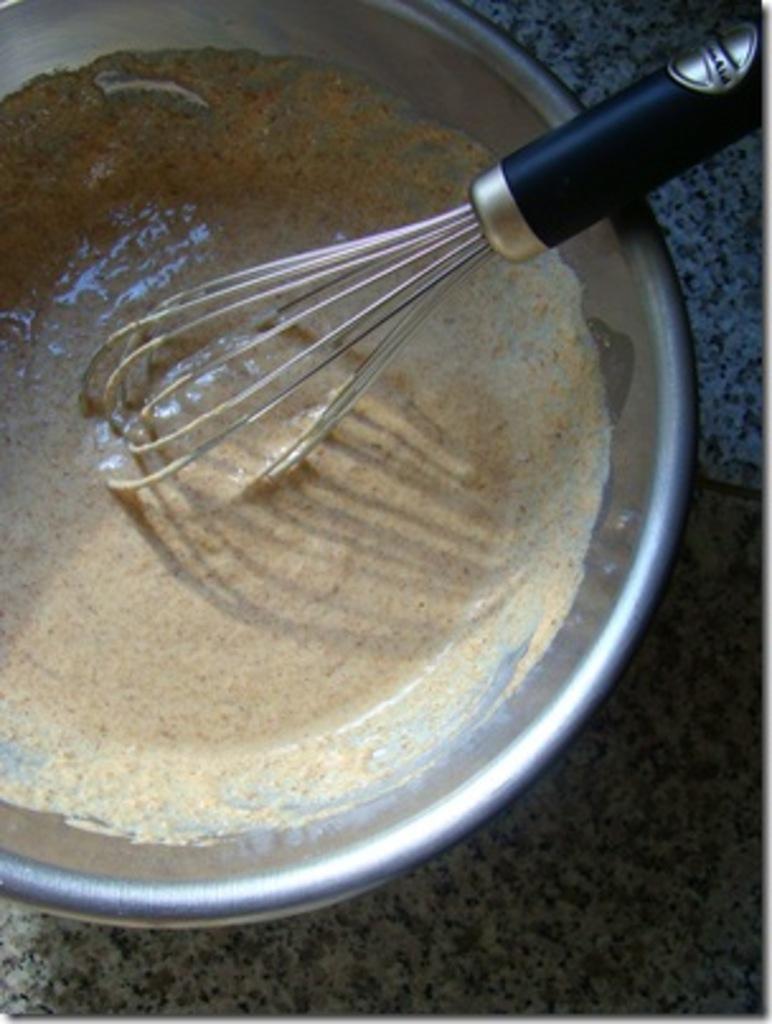How would you summarize this image in a sentence or two? In this image we can see a food item in the bowl, also we can see the egg beater, which are on the granite. 